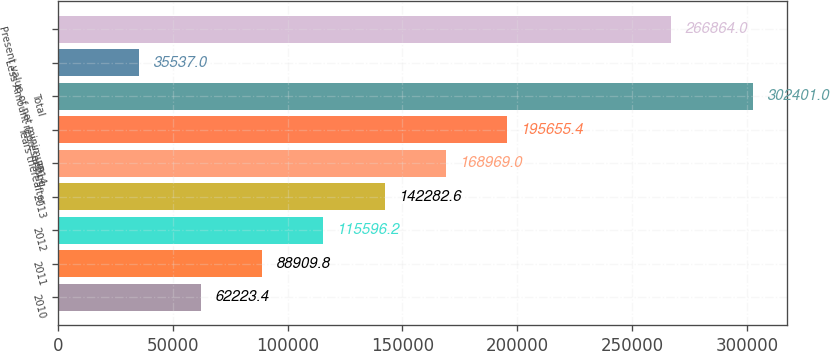Convert chart. <chart><loc_0><loc_0><loc_500><loc_500><bar_chart><fcel>2010<fcel>2011<fcel>2012<fcel>2013<fcel>2014<fcel>Years thereafter<fcel>Total<fcel>Less Amount representing<fcel>Present value of net minimum<nl><fcel>62223.4<fcel>88909.8<fcel>115596<fcel>142283<fcel>168969<fcel>195655<fcel>302401<fcel>35537<fcel>266864<nl></chart> 